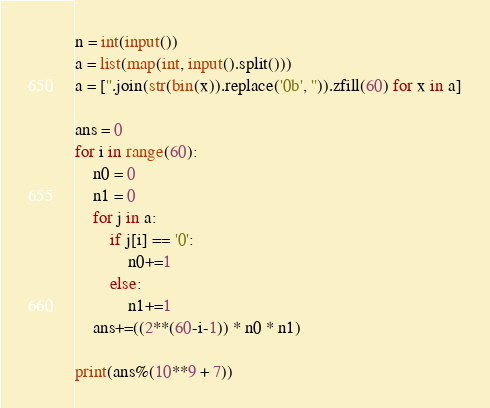Convert code to text. <code><loc_0><loc_0><loc_500><loc_500><_Python_>n = int(input())
a = list(map(int, input().split()))
a = [''.join(str(bin(x)).replace('0b', '')).zfill(60) for x in a]

ans = 0
for i in range(60):
    n0 = 0
    n1 = 0
    for j in a:
        if j[i] == '0':
            n0+=1
        else:
            n1+=1
    ans+=((2**(60-i-1)) * n0 * n1)
    
print(ans%(10**9 + 7))</code> 